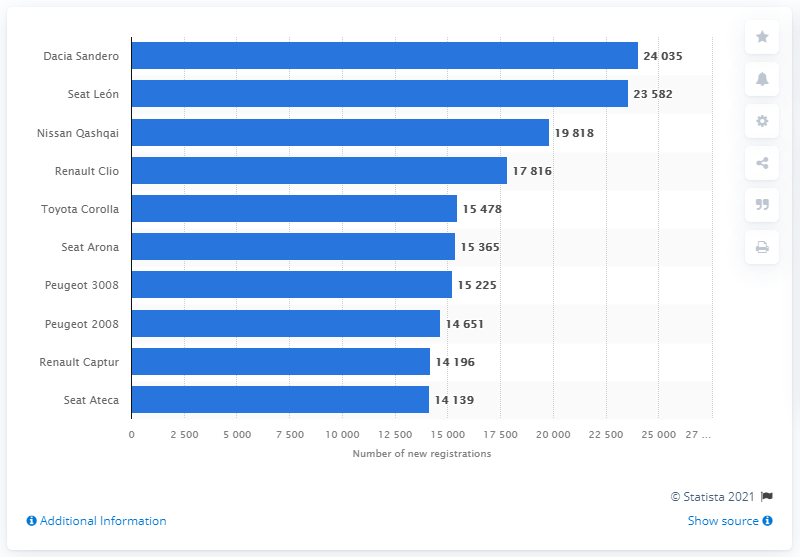Specify some key components in this picture. The Dacia Sandero was the most registered passenger car model in Spain in 2020. In 2020, the Dacia Sandero had a total of 24,035 registrations. 